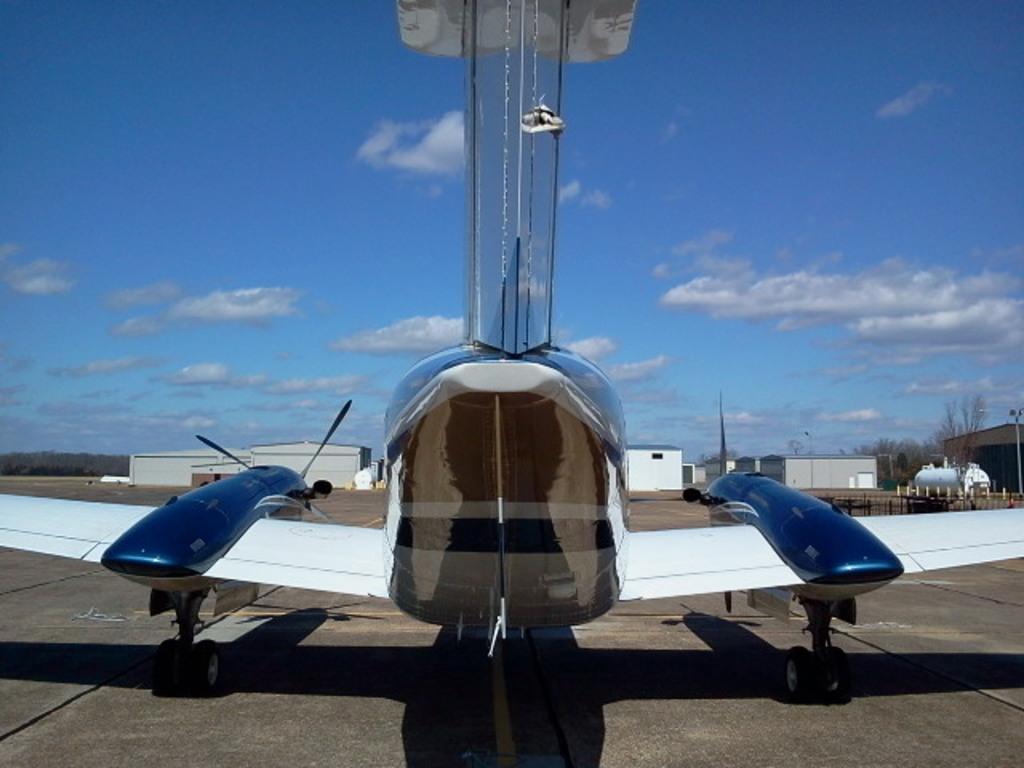In one or two sentences, can you explain what this image depicts? This is a picture of an airplane, on runway. In the background there are buildings and trees. Sky is clear and it is sunny. 